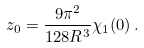Convert formula to latex. <formula><loc_0><loc_0><loc_500><loc_500>z _ { 0 } = \frac { 9 \pi ^ { 2 } } { 1 2 8 R ^ { 3 } } \chi _ { 1 } ( 0 ) \, .</formula> 